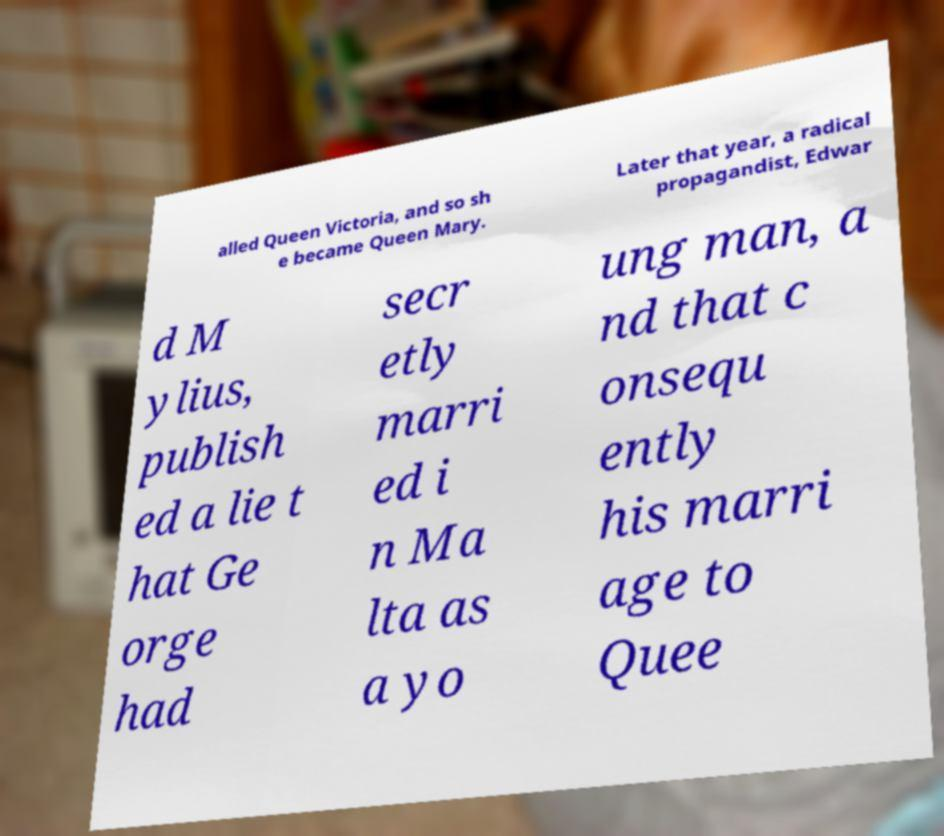What messages or text are displayed in this image? I need them in a readable, typed format. alled Queen Victoria, and so sh e became Queen Mary. Later that year, a radical propagandist, Edwar d M ylius, publish ed a lie t hat Ge orge had secr etly marri ed i n Ma lta as a yo ung man, a nd that c onsequ ently his marri age to Quee 